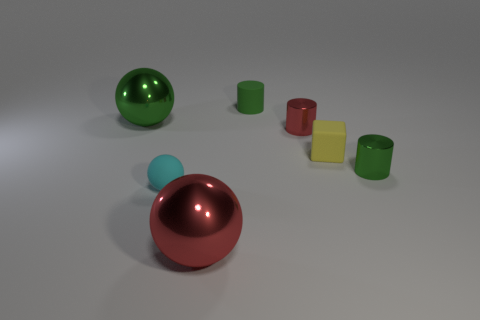How many green cylinders must be subtracted to get 1 green cylinders? 1 Add 2 red metal cylinders. How many objects exist? 9 Subtract all cylinders. How many objects are left? 4 Add 6 big red metal spheres. How many big red metal spheres are left? 7 Add 5 large green shiny cylinders. How many large green shiny cylinders exist? 5 Subtract 0 brown cylinders. How many objects are left? 7 Subtract all tiny matte balls. Subtract all tiny green cylinders. How many objects are left? 4 